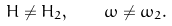Convert formula to latex. <formula><loc_0><loc_0><loc_500><loc_500>H \neq H _ { 2 } , \quad \omega \neq \omega _ { 2 } .</formula> 